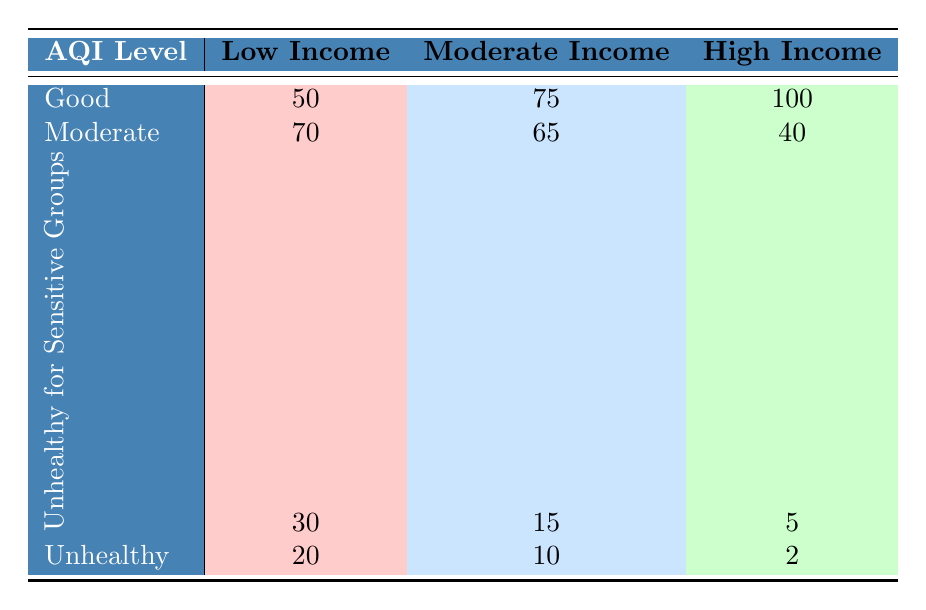What is the count of the "Good" AQI level in the Low Income area? According to the table, the "Good" AQI level count for the Low Income area is presented directly in the corresponding cell.
Answer: 50 What is the total count of "Unhealthy" AQI levels across all socioeconomic areas? To find the total count for "Unhealthy", I add the counts from all areas: Low Income (20) + Moderate Income (10) + High Income (2) = 32.
Answer: 32 Which socioeconomic area has the highest count for the "Moderate" AQI level? The counts for the "Moderate" AQI level are Low Income (70), Moderate Income (65), and High Income (40). The highest is from the Low Income area with a count of 70.
Answer: Low Income Is there any area with a count of 0 for “Unhealthy for Sensitive Groups”? The counts for "Unhealthy for Sensitive Groups" are Low Income (30), Moderate Income (15), and High Income (5). None of the areas have a count of 0.
Answer: No What is the average count of the "Good" AQI levels across the socioeconomic areas? The counts for "Good" AQI levels are Low Income (50), Moderate Income (75), and High Income (100). The sum is 50 + 75 + 100 = 225. Since there are 3 areas, the average is 225 / 3 = 75.
Answer: 75 How many total AQI counts are there in the High Income area? The counts for the High Income area are: Good (100), Moderate (40), Unhealthy for Sensitive Groups (5), and Unhealthy (2). Adding them: 100 + 40 + 5 + 2 = 147.
Answer: 147 In which socioeconomic area do more than 30 counts fall under "Unhealthy for Sensitive Groups"? The counts for "Unhealthy for Sensitive Groups" are: Low Income (30), Moderate Income (15), and High Income (5). Only the Low Income area has counts equal to 30 but not more.
Answer: No Which AQI level has the lowest count in the High Income area? The counts for the High Income area are: Good (100), Moderate (40), Unhealthy for Sensitive Groups (5), and Unhealthy (2). The lowest count is for the "Unhealthy" AQI level with a count of 2.
Answer: Unhealthy 